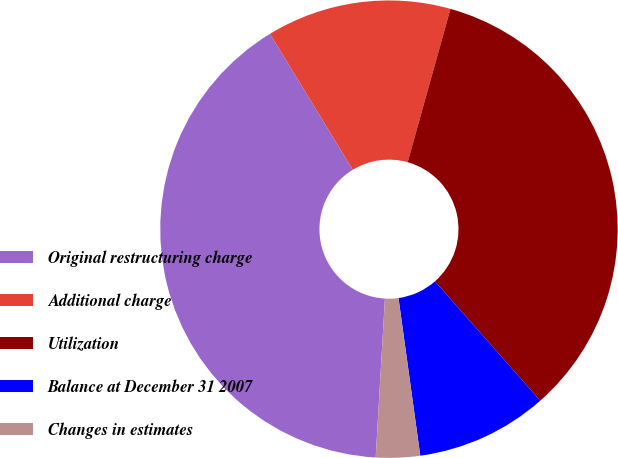Convert chart. <chart><loc_0><loc_0><loc_500><loc_500><pie_chart><fcel>Original restructuring charge<fcel>Additional charge<fcel>Utilization<fcel>Balance at December 31 2007<fcel>Changes in estimates<nl><fcel>40.37%<fcel>13.04%<fcel>34.16%<fcel>9.32%<fcel>3.11%<nl></chart> 